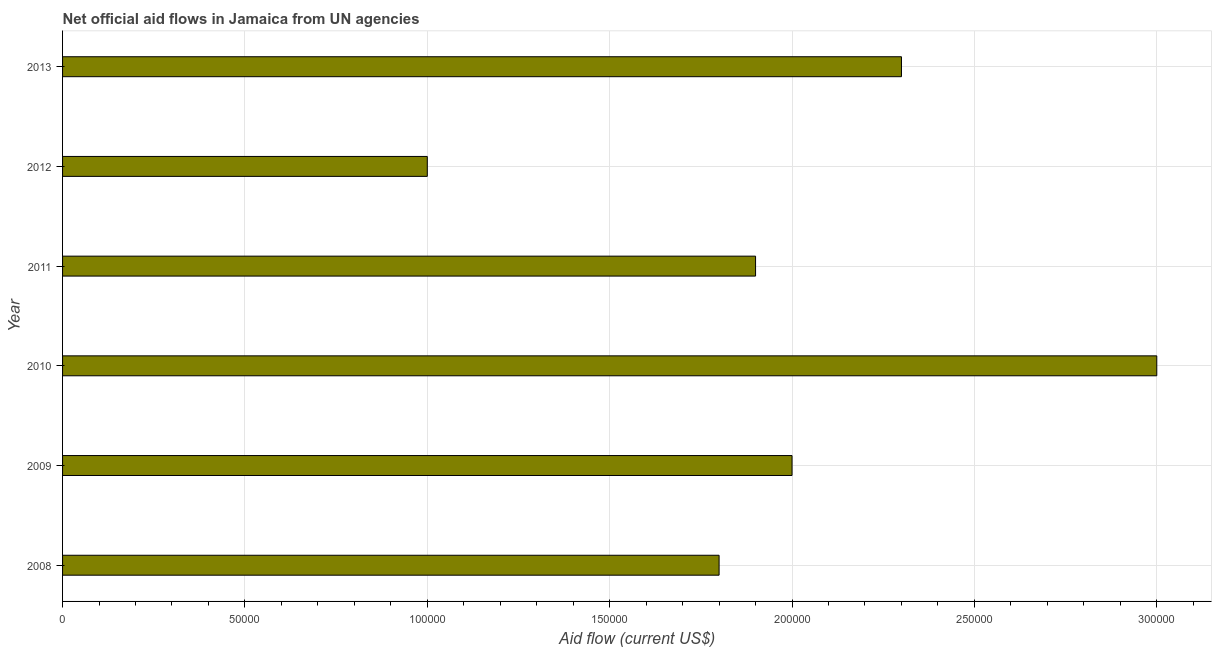Does the graph contain any zero values?
Provide a succinct answer. No. Does the graph contain grids?
Offer a very short reply. Yes. What is the title of the graph?
Offer a terse response. Net official aid flows in Jamaica from UN agencies. What is the net official flows from un agencies in 2011?
Provide a short and direct response. 1.90e+05. Across all years, what is the minimum net official flows from un agencies?
Your answer should be very brief. 1.00e+05. In which year was the net official flows from un agencies minimum?
Make the answer very short. 2012. What is the sum of the net official flows from un agencies?
Offer a very short reply. 1.20e+06. What is the average net official flows from un agencies per year?
Make the answer very short. 2.00e+05. What is the median net official flows from un agencies?
Give a very brief answer. 1.95e+05. Do a majority of the years between 2011 and 2010 (inclusive) have net official flows from un agencies greater than 190000 US$?
Offer a very short reply. No. What is the ratio of the net official flows from un agencies in 2008 to that in 2009?
Ensure brevity in your answer.  0.9. Is the net official flows from un agencies in 2009 less than that in 2012?
Ensure brevity in your answer.  No. Is the difference between the net official flows from un agencies in 2008 and 2012 greater than the difference between any two years?
Your response must be concise. No. Is the sum of the net official flows from un agencies in 2009 and 2010 greater than the maximum net official flows from un agencies across all years?
Make the answer very short. Yes. What is the difference between the highest and the lowest net official flows from un agencies?
Make the answer very short. 2.00e+05. In how many years, is the net official flows from un agencies greater than the average net official flows from un agencies taken over all years?
Your response must be concise. 2. How many bars are there?
Give a very brief answer. 6. How many years are there in the graph?
Provide a succinct answer. 6. What is the difference between two consecutive major ticks on the X-axis?
Provide a short and direct response. 5.00e+04. Are the values on the major ticks of X-axis written in scientific E-notation?
Provide a succinct answer. No. What is the Aid flow (current US$) of 2011?
Your response must be concise. 1.90e+05. What is the Aid flow (current US$) of 2012?
Provide a succinct answer. 1.00e+05. What is the difference between the Aid flow (current US$) in 2008 and 2010?
Your answer should be compact. -1.20e+05. What is the difference between the Aid flow (current US$) in 2008 and 2011?
Make the answer very short. -10000. What is the difference between the Aid flow (current US$) in 2008 and 2013?
Offer a very short reply. -5.00e+04. What is the difference between the Aid flow (current US$) in 2010 and 2011?
Give a very brief answer. 1.10e+05. What is the difference between the Aid flow (current US$) in 2010 and 2012?
Give a very brief answer. 2.00e+05. What is the difference between the Aid flow (current US$) in 2011 and 2012?
Offer a very short reply. 9.00e+04. What is the ratio of the Aid flow (current US$) in 2008 to that in 2010?
Give a very brief answer. 0.6. What is the ratio of the Aid flow (current US$) in 2008 to that in 2011?
Make the answer very short. 0.95. What is the ratio of the Aid flow (current US$) in 2008 to that in 2013?
Keep it short and to the point. 0.78. What is the ratio of the Aid flow (current US$) in 2009 to that in 2010?
Your answer should be very brief. 0.67. What is the ratio of the Aid flow (current US$) in 2009 to that in 2011?
Offer a terse response. 1.05. What is the ratio of the Aid flow (current US$) in 2009 to that in 2013?
Your response must be concise. 0.87. What is the ratio of the Aid flow (current US$) in 2010 to that in 2011?
Offer a very short reply. 1.58. What is the ratio of the Aid flow (current US$) in 2010 to that in 2012?
Offer a very short reply. 3. What is the ratio of the Aid flow (current US$) in 2010 to that in 2013?
Offer a terse response. 1.3. What is the ratio of the Aid flow (current US$) in 2011 to that in 2013?
Provide a succinct answer. 0.83. What is the ratio of the Aid flow (current US$) in 2012 to that in 2013?
Offer a terse response. 0.43. 